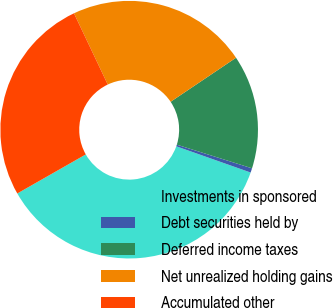Convert chart. <chart><loc_0><loc_0><loc_500><loc_500><pie_chart><fcel>Investments in sponsored<fcel>Debt securities held by<fcel>Deferred income taxes<fcel>Net unrealized holding gains<fcel>Accumulated other<nl><fcel>36.35%<fcel>0.55%<fcel>14.28%<fcel>22.62%<fcel>26.2%<nl></chart> 